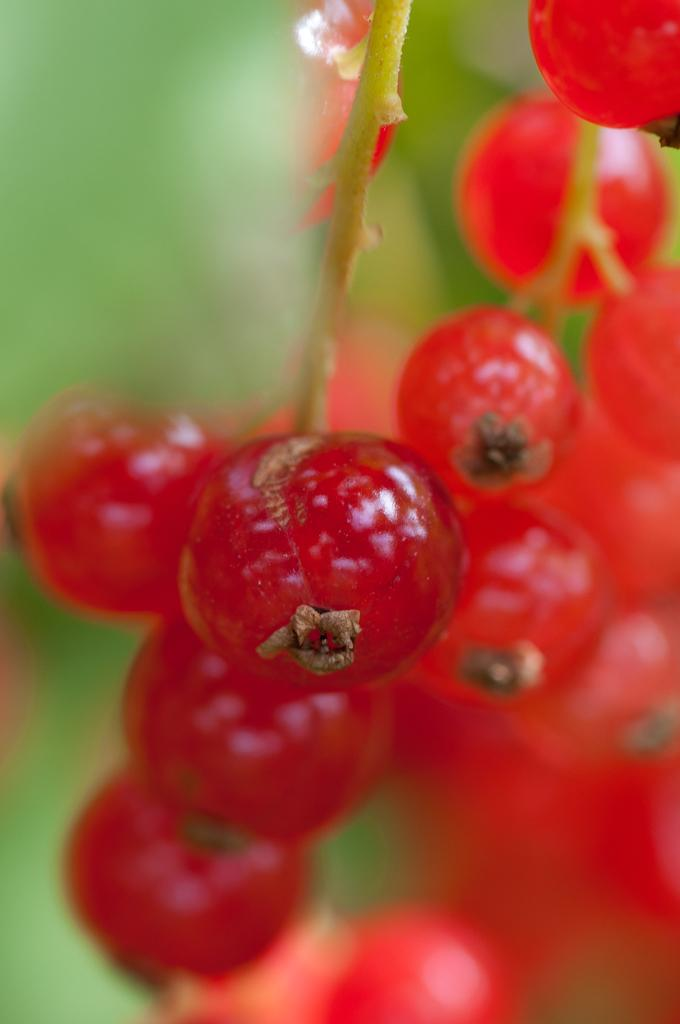What type of fruit is visible in the picture? There are cherries in the picture. Where are the cherries located on the plant? The cherries are on the branch of a plant. What is the color of the cherries? The cherries are red in color. What type of religious symbol can be seen on the ground near the cherries? There is no religious symbol present on the ground near the cherries in the image. 